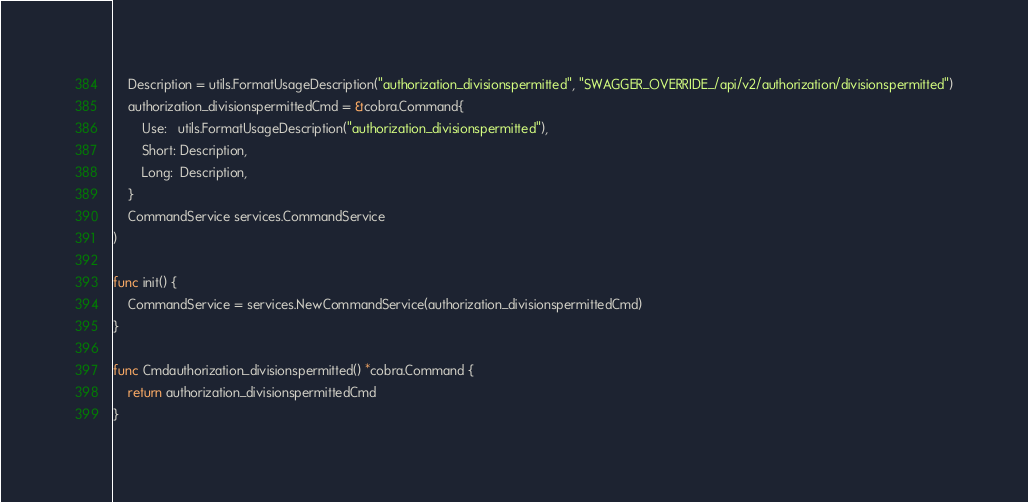<code> <loc_0><loc_0><loc_500><loc_500><_Go_>	Description = utils.FormatUsageDescription("authorization_divisionspermitted", "SWAGGER_OVERRIDE_/api/v2/authorization/divisionspermitted")
	authorization_divisionspermittedCmd = &cobra.Command{
		Use:   utils.FormatUsageDescription("authorization_divisionspermitted"),
		Short: Description,
		Long:  Description,
	}
	CommandService services.CommandService
)

func init() {
	CommandService = services.NewCommandService(authorization_divisionspermittedCmd)
}

func Cmdauthorization_divisionspermitted() *cobra.Command {
	return authorization_divisionspermittedCmd
}
</code> 